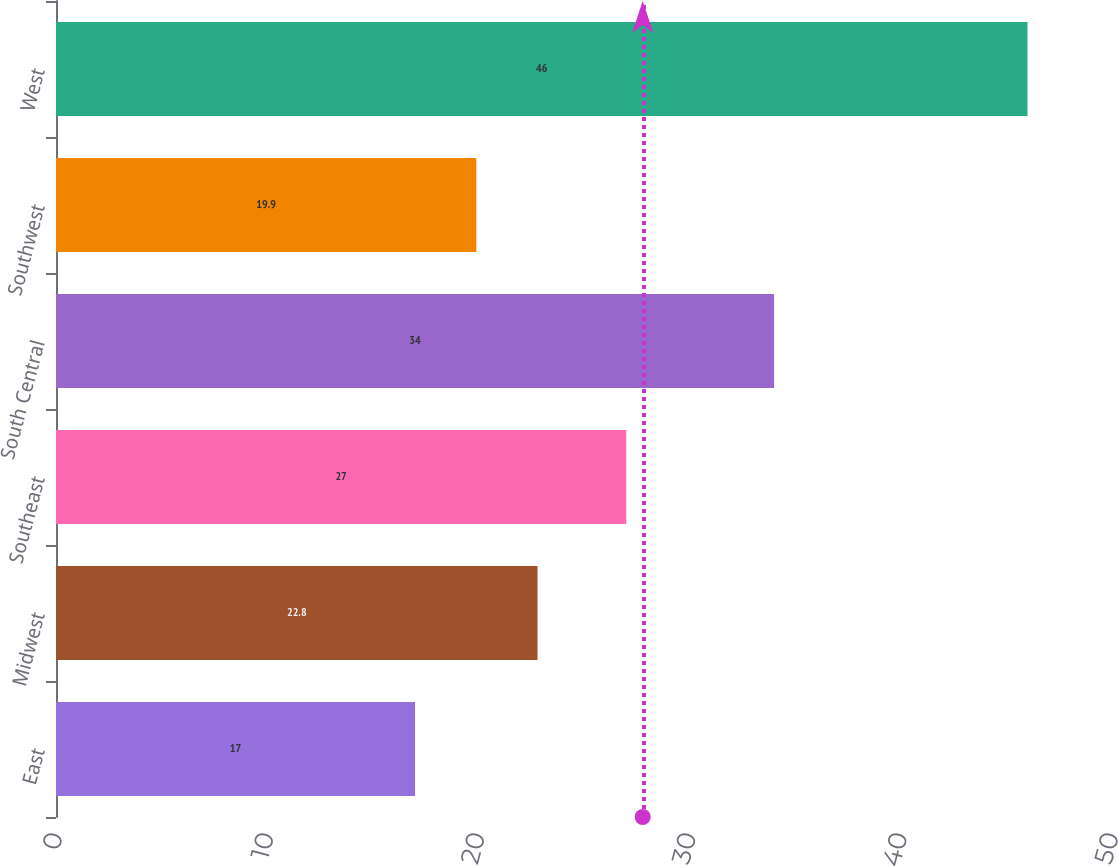Convert chart to OTSL. <chart><loc_0><loc_0><loc_500><loc_500><bar_chart><fcel>East<fcel>Midwest<fcel>Southeast<fcel>South Central<fcel>Southwest<fcel>West<nl><fcel>17<fcel>22.8<fcel>27<fcel>34<fcel>19.9<fcel>46<nl></chart> 